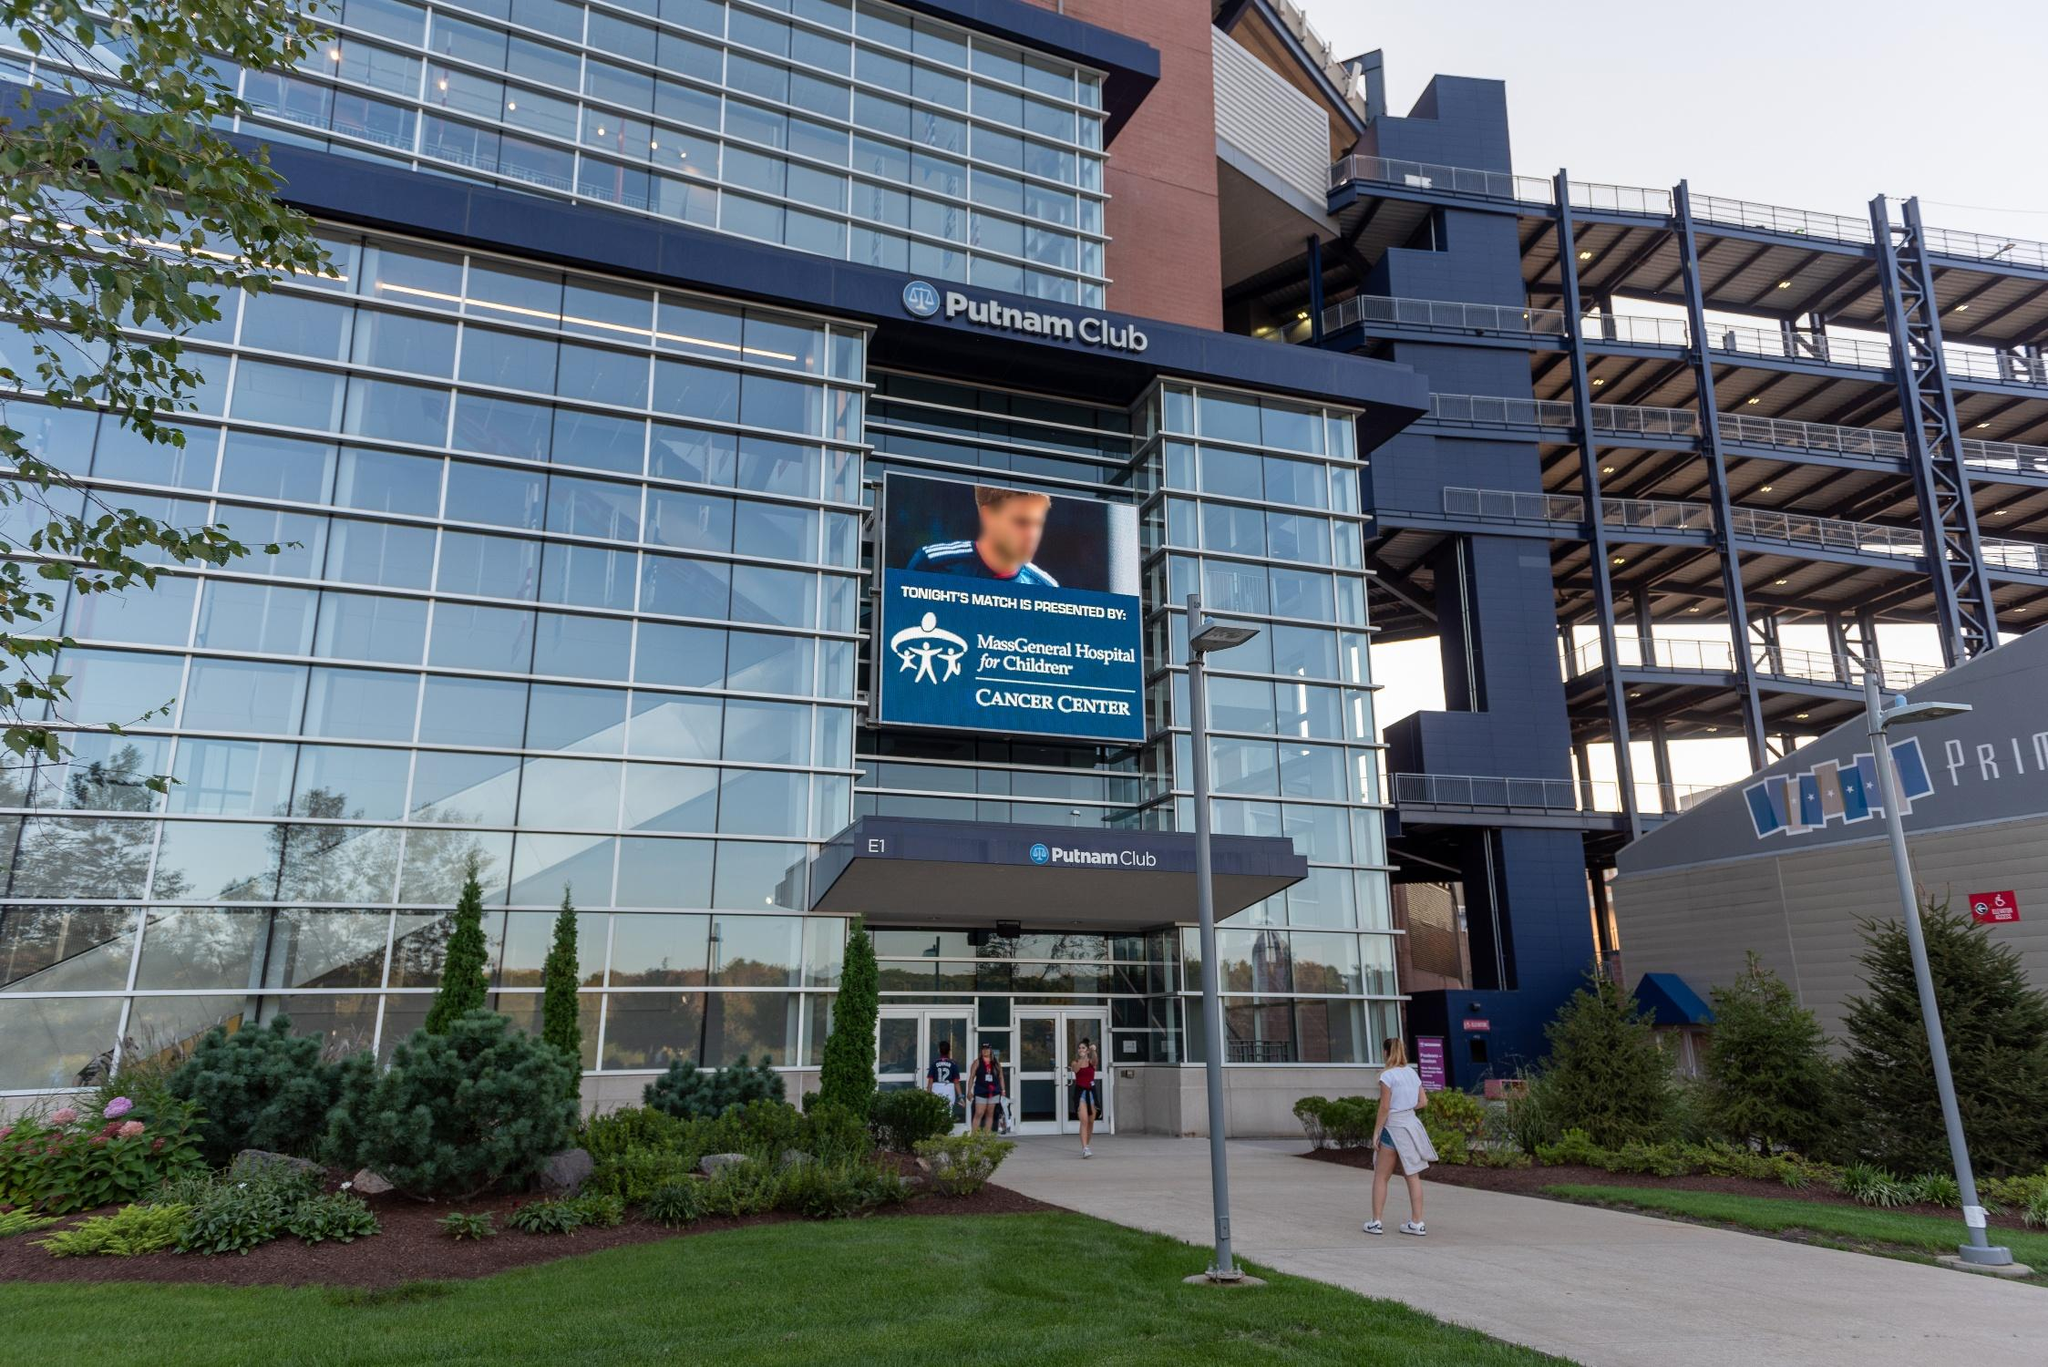Describe the atmosphere and potential experience for visitors arriving at this venue. Visitors arriving at the Putnam Club are likely to experience a mix of excitement and anticipation. The modern architecture, coupled with the expansive glass façade, provides an open and welcoming ambience. The lush landscaping adds a serene touch, offering a pleasant first impression. As visitors approach the entrance, the prominent digital screen showcasing health-related advertisements reflects the venue’s commitment to community welfare. The sleek exterior hints at the state-of-the-art amenities and premium services that await inside, promising an enjoyable and memorable visit. 